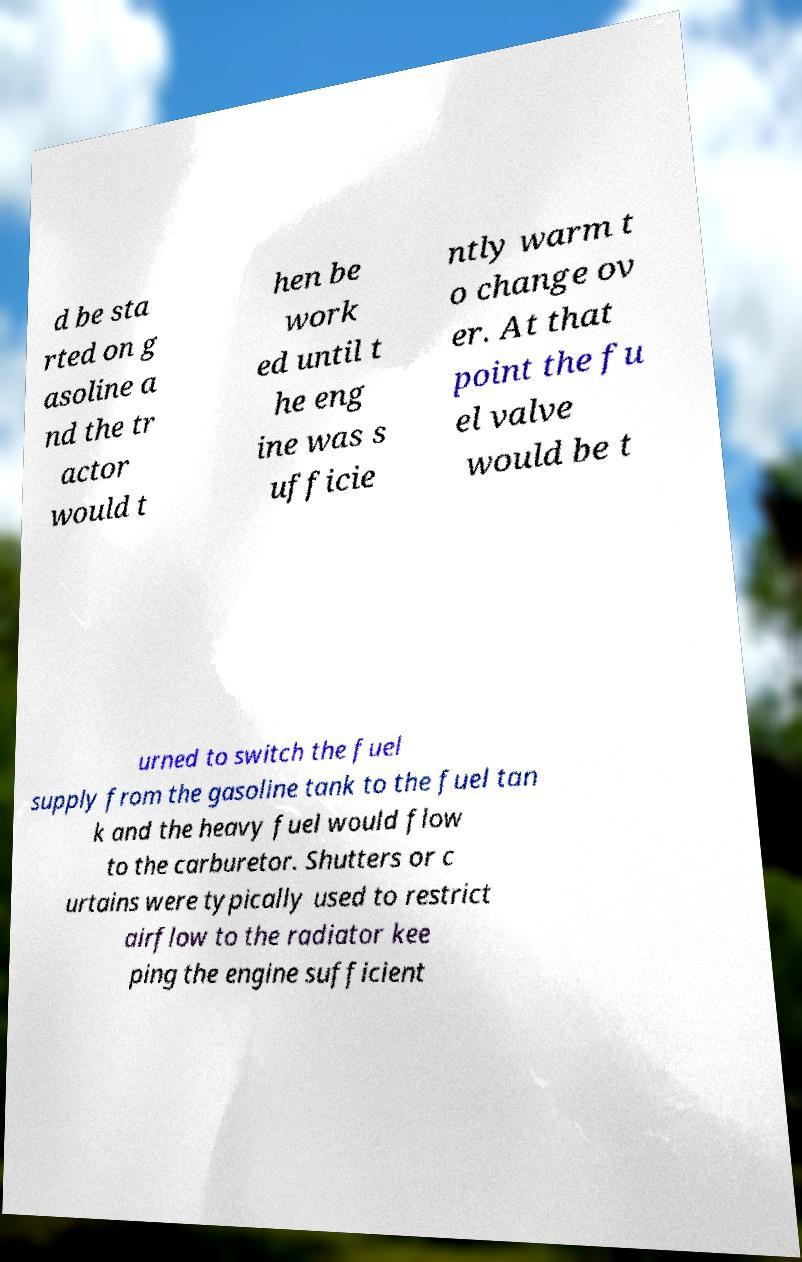There's text embedded in this image that I need extracted. Can you transcribe it verbatim? d be sta rted on g asoline a nd the tr actor would t hen be work ed until t he eng ine was s ufficie ntly warm t o change ov er. At that point the fu el valve would be t urned to switch the fuel supply from the gasoline tank to the fuel tan k and the heavy fuel would flow to the carburetor. Shutters or c urtains were typically used to restrict airflow to the radiator kee ping the engine sufficient 